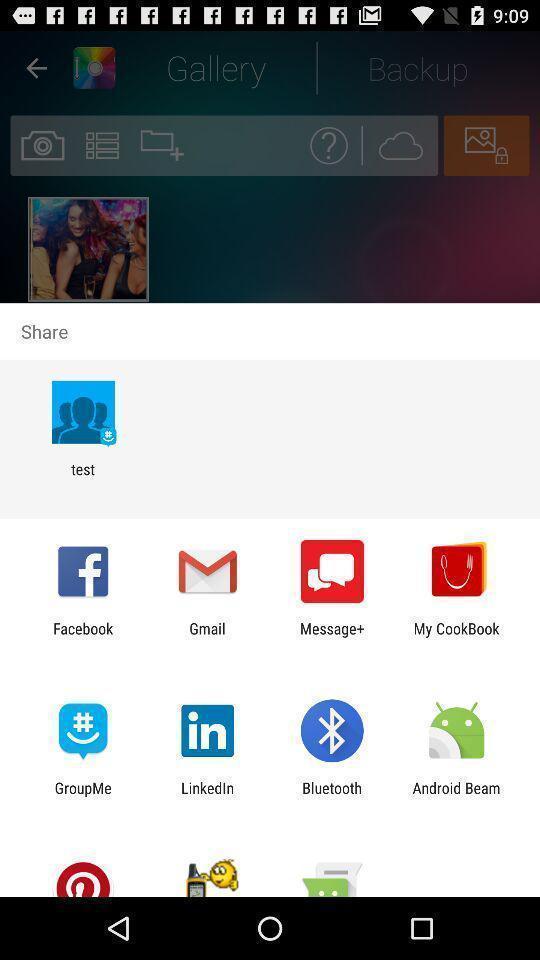Summarize the main components in this picture. Screen showing various applications to share. 